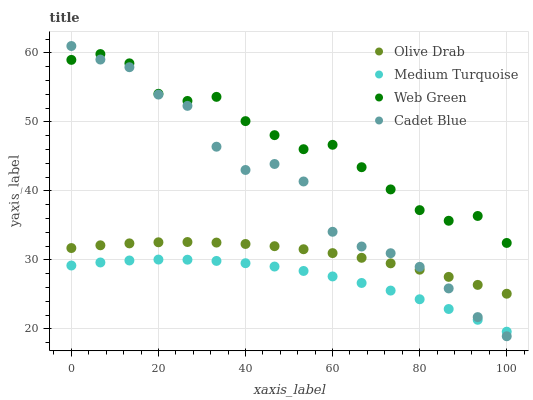Does Medium Turquoise have the minimum area under the curve?
Answer yes or no. Yes. Does Web Green have the maximum area under the curve?
Answer yes or no. Yes. Does Web Green have the minimum area under the curve?
Answer yes or no. No. Does Medium Turquoise have the maximum area under the curve?
Answer yes or no. No. Is Olive Drab the smoothest?
Answer yes or no. Yes. Is Cadet Blue the roughest?
Answer yes or no. Yes. Is Web Green the smoothest?
Answer yes or no. No. Is Web Green the roughest?
Answer yes or no. No. Does Cadet Blue have the lowest value?
Answer yes or no. Yes. Does Medium Turquoise have the lowest value?
Answer yes or no. No. Does Cadet Blue have the highest value?
Answer yes or no. Yes. Does Web Green have the highest value?
Answer yes or no. No. Is Medium Turquoise less than Olive Drab?
Answer yes or no. Yes. Is Olive Drab greater than Medium Turquoise?
Answer yes or no. Yes. Does Cadet Blue intersect Web Green?
Answer yes or no. Yes. Is Cadet Blue less than Web Green?
Answer yes or no. No. Is Cadet Blue greater than Web Green?
Answer yes or no. No. Does Medium Turquoise intersect Olive Drab?
Answer yes or no. No. 